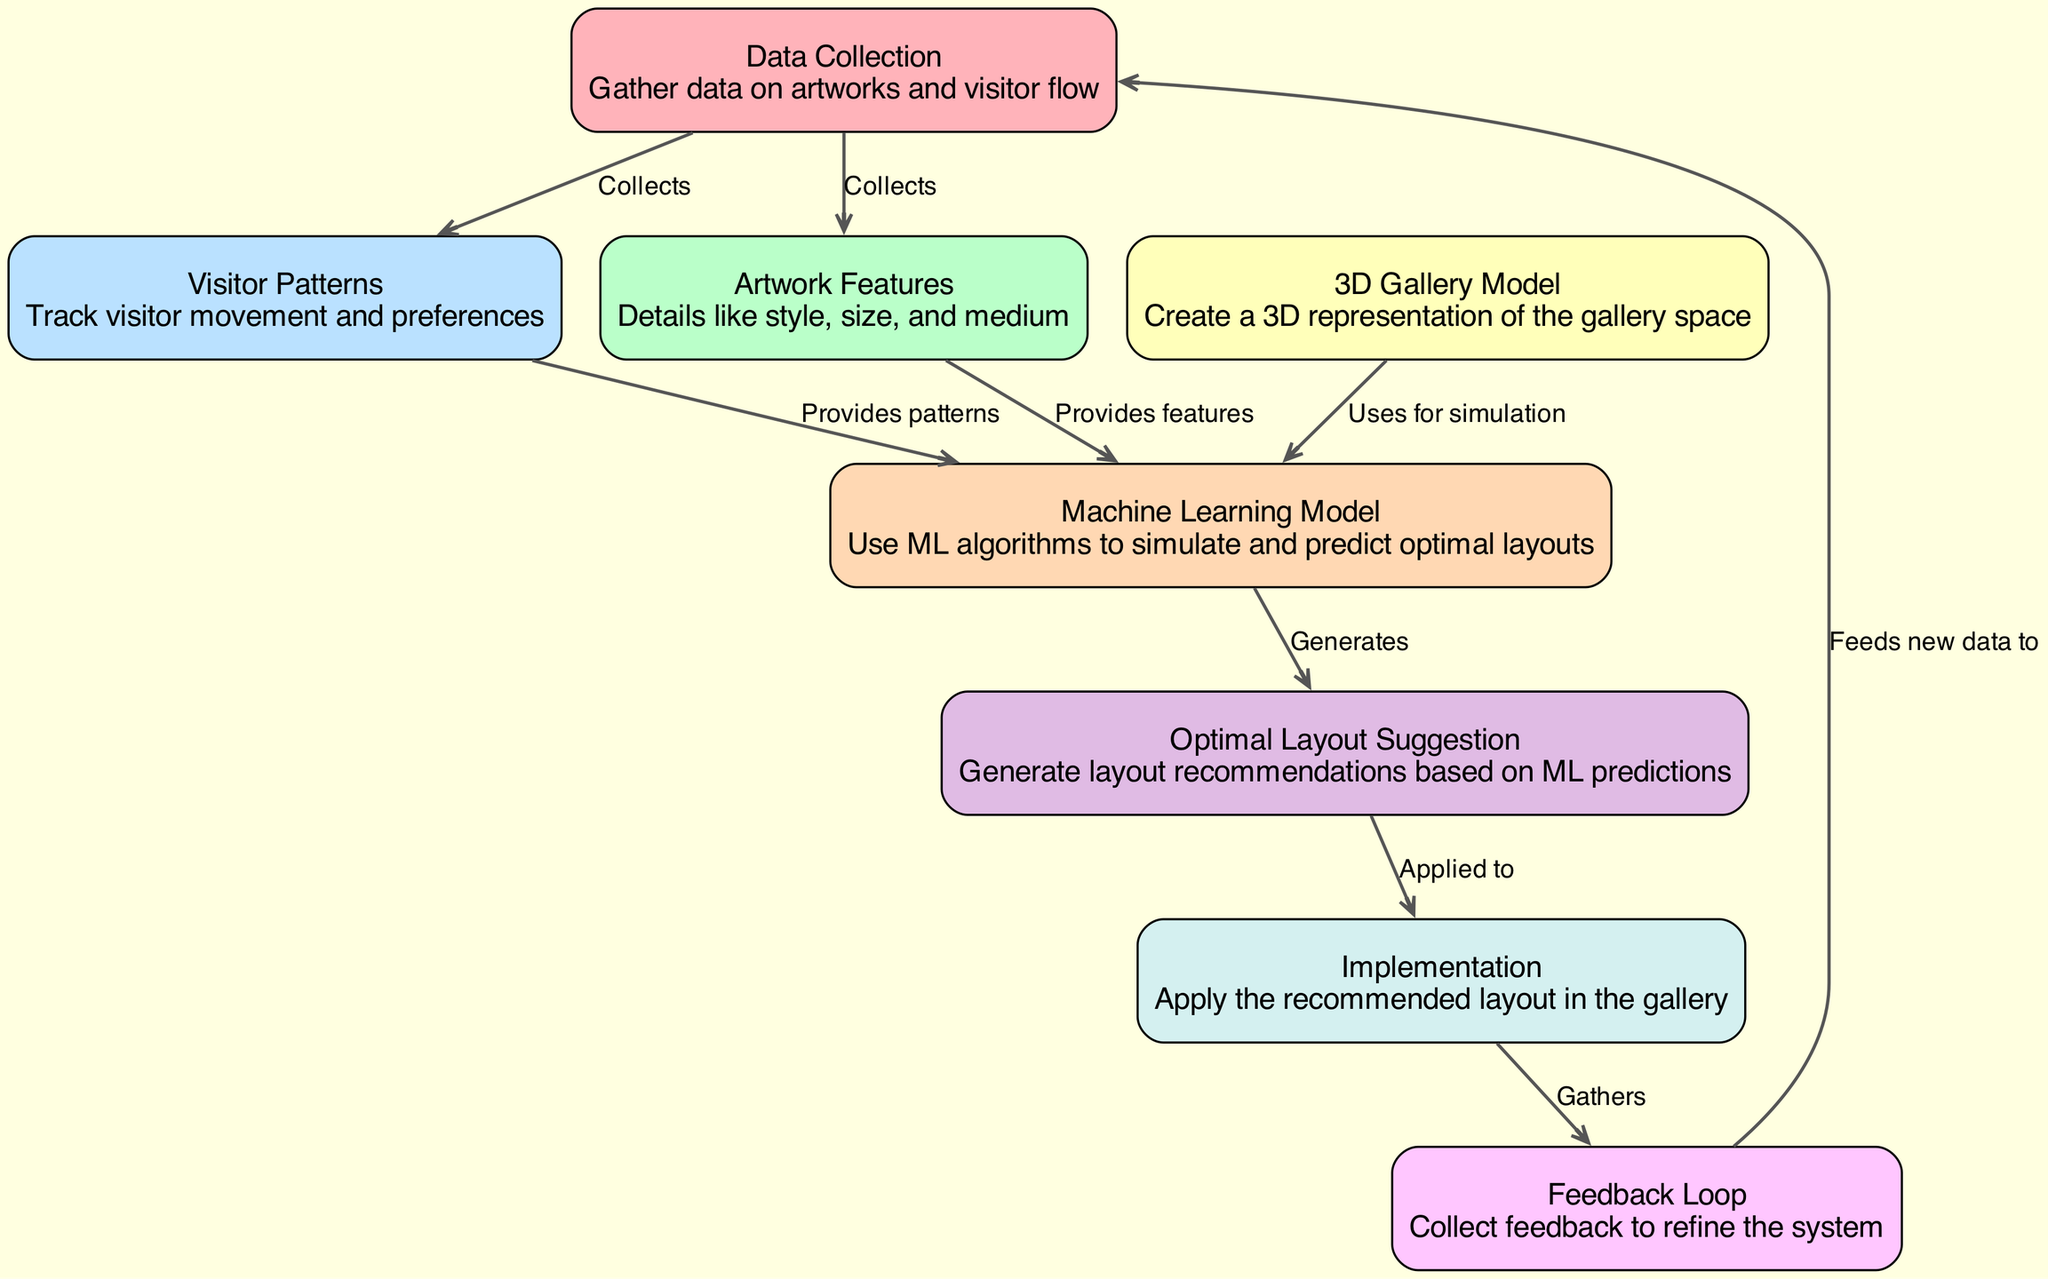What is the first node in the diagram? The first node is "Data Collection," which is identified by the ID "1." This is the starting point for gathering data on artworks and visitor flow.
Answer: Data Collection How many edges are there in total? By counting the connections (edges) between the nodes, there are a total of 9 edges illustrated in the diagram.
Answer: 9 What information does the node "Artwork Features" provide? "Artwork Features" provides details about the artworks, such as their style, size, and medium. This information is essential for the Machine Learning Model to analyze the artworks effectively.
Answer: Details like style, size, and medium Which nodes directly feed into the "Machine Learning Model"? The nodes that directly feed into the "Machine Learning Model" are "Artwork Features" and "Visitor Patterns." Both provide essential information required for simulating optimal gallery layouts.
Answer: Artwork Features, Visitor Patterns What is the output of the "Machine Learning Model"? The output of the "Machine Learning Model" is "Optimal Layout Suggestion," which indicates that the model generates recommendations for layout based on previous data and simulations.
Answer: Optimal Layout Suggestion How does the "Feedback Loop" interact with the "Implementation" node? The "Feedback Loop" gathers feedback after implementing the "Optimal Layout Suggestion," which provides insights that can improve future iterations of the entire system, creating a cycle of refinement.
Answer: Gathers What is the function of the "3D Gallery Model"? The "3D Gallery Model" serves to create a three-dimensional representation of the gallery space, allowing for better spatial planning in conjunction with the machine learning simulations.
Answer: Create a 3D representation of the gallery space Which node is positioned at the end of the flow? The final node in the flow is "Feedback Loop," which ensures that the system continuously improves by feeding new data back into the initial stage of data collection.
Answer: Feedback Loop What is the relationship between "Data Collection" and "Visitor Patterns"? "Data Collection" collects data on both artworks and visitor flow, establishing that "Visitor Patterns" is one aspect of the overall data gathering effort.
Answer: Collects 